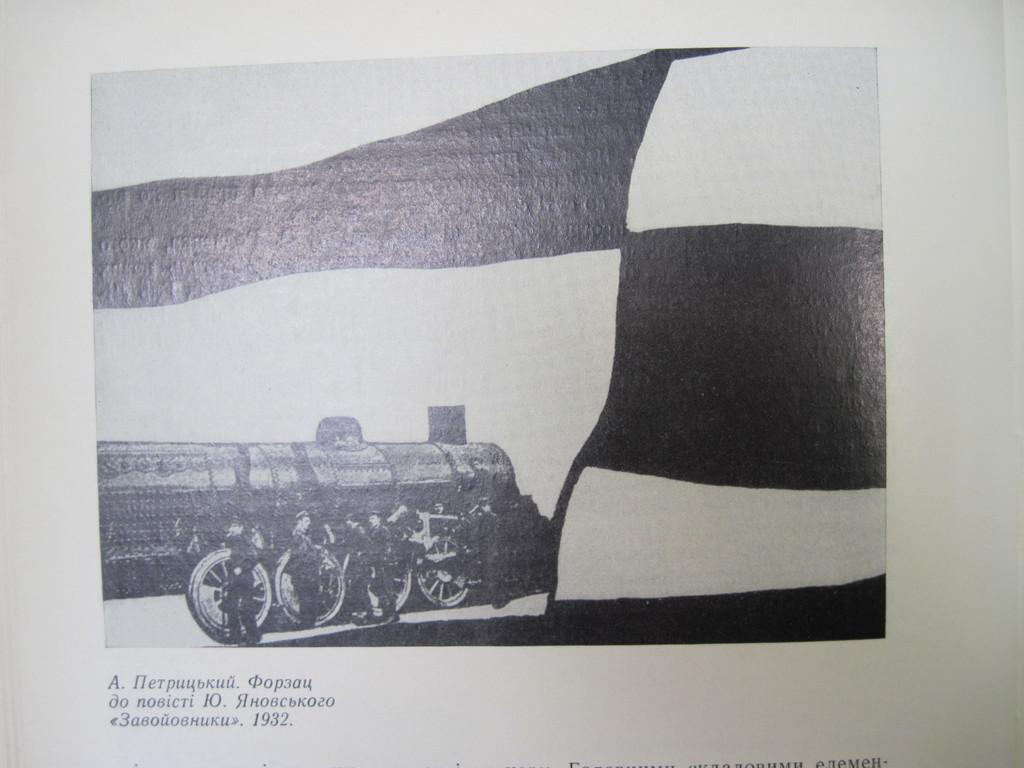What is featured on the poster in the image? The poster contains an image of a train. What else can be seen on the poster besides the train? There is text on the poster. What is the weight of the sink in the image? There is no sink present in the image; it only features a poster with an image of a train and text. 